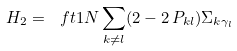Convert formula to latex. <formula><loc_0><loc_0><loc_500><loc_500>H _ { 2 } = \ f t 1 { N } \sum _ { k \neq l } ( 2 - 2 \, P _ { k l } ) \Sigma _ { k \gamma _ { l } }</formula> 